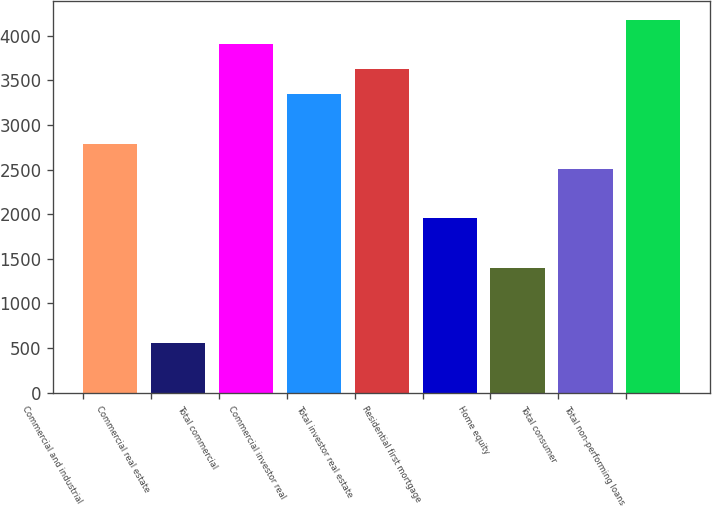<chart> <loc_0><loc_0><loc_500><loc_500><bar_chart><fcel>Commercial and industrial<fcel>Commercial real estate<fcel>Total commercial<fcel>Commercial investor real<fcel>Total investor real estate<fcel>Residential first mortgage<fcel>Home equity<fcel>Total consumer<fcel>Total non-performing loans<nl><fcel>2789<fcel>560.2<fcel>3903.4<fcel>3346.2<fcel>3624.8<fcel>1953.2<fcel>1396<fcel>2510.4<fcel>4182<nl></chart> 